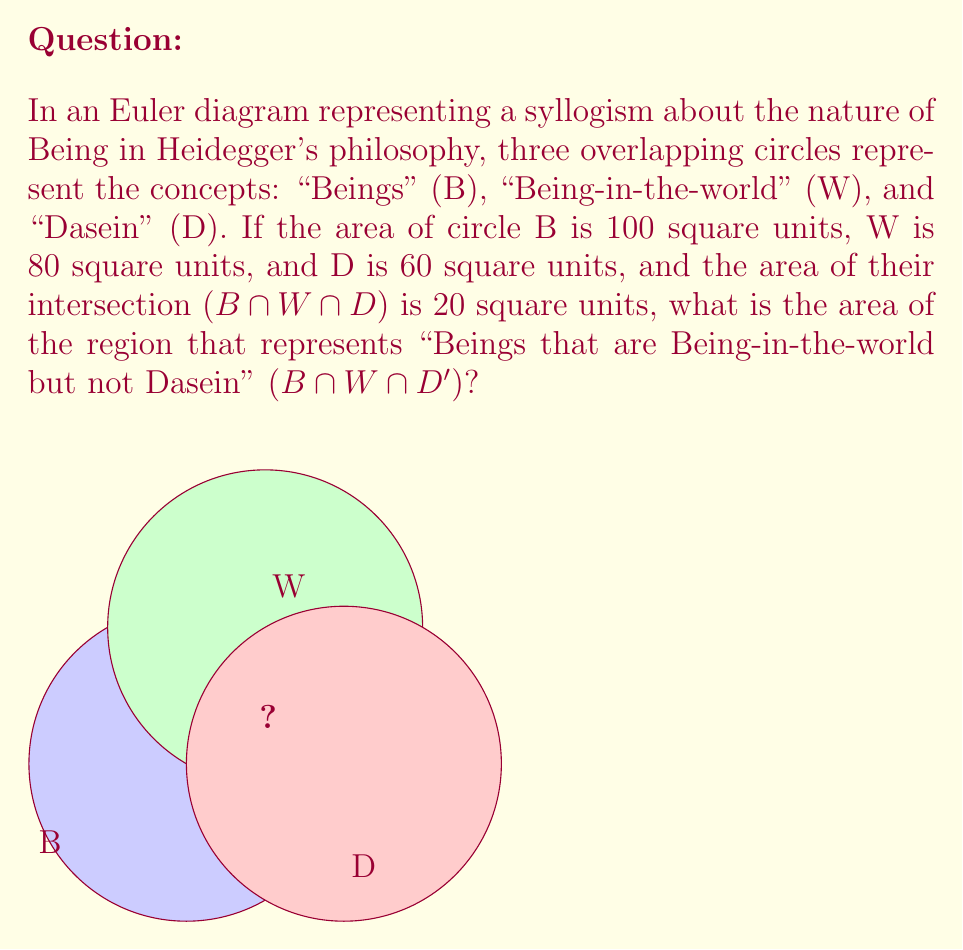Solve this math problem. To solve this problem, we'll use the principles of set theory as applied to Euler diagrams. Let's break it down step-by-step:

1) First, we need to find the area of B ∩ W (the intersection of Beings and Being-in-the-world). We can use the inclusion-exclusion principle:

   $$(B \cap W) = B + W - (B \cup W)$$

2) We don't know (B ∪ W), but we can find it using:

   $$(B \cup W) = B + W - (B \cap W)$$

3) We know that (B ∩ W) must include (B ∩ W ∩ D), so:

   $$(B \cap W) = (B \cap W \cap D) + (B \cap W \cap D')$$

4) Let x = (B ∩ W ∩ D'). Then:

   $$80 + 100 - (B \cup W) = 20 + x$$

5) Solving for (B ∪ W):

   $$(B \cup W) = 180 - 20 - x = 160 - x$$

6) Substituting this back into the equation from step 1:

   $$100 + 80 - (160 - x) = 20 + x$$

7) Simplifying:

   $$20 + x = 20 + x$$

Therefore, our solution is consistent, but we need more information to determine x uniquely. However, we can conclude that the area of (B ∩ W ∩ D') is indeed x.

This indeterminacy mirrors Heidegger's concept of the "clearing" (Lichtung) in Being and Time, where the boundaries between Being, beings, and Dasein are not always clearly delineated.
Answer: The problem is indeterminate with the given information. 